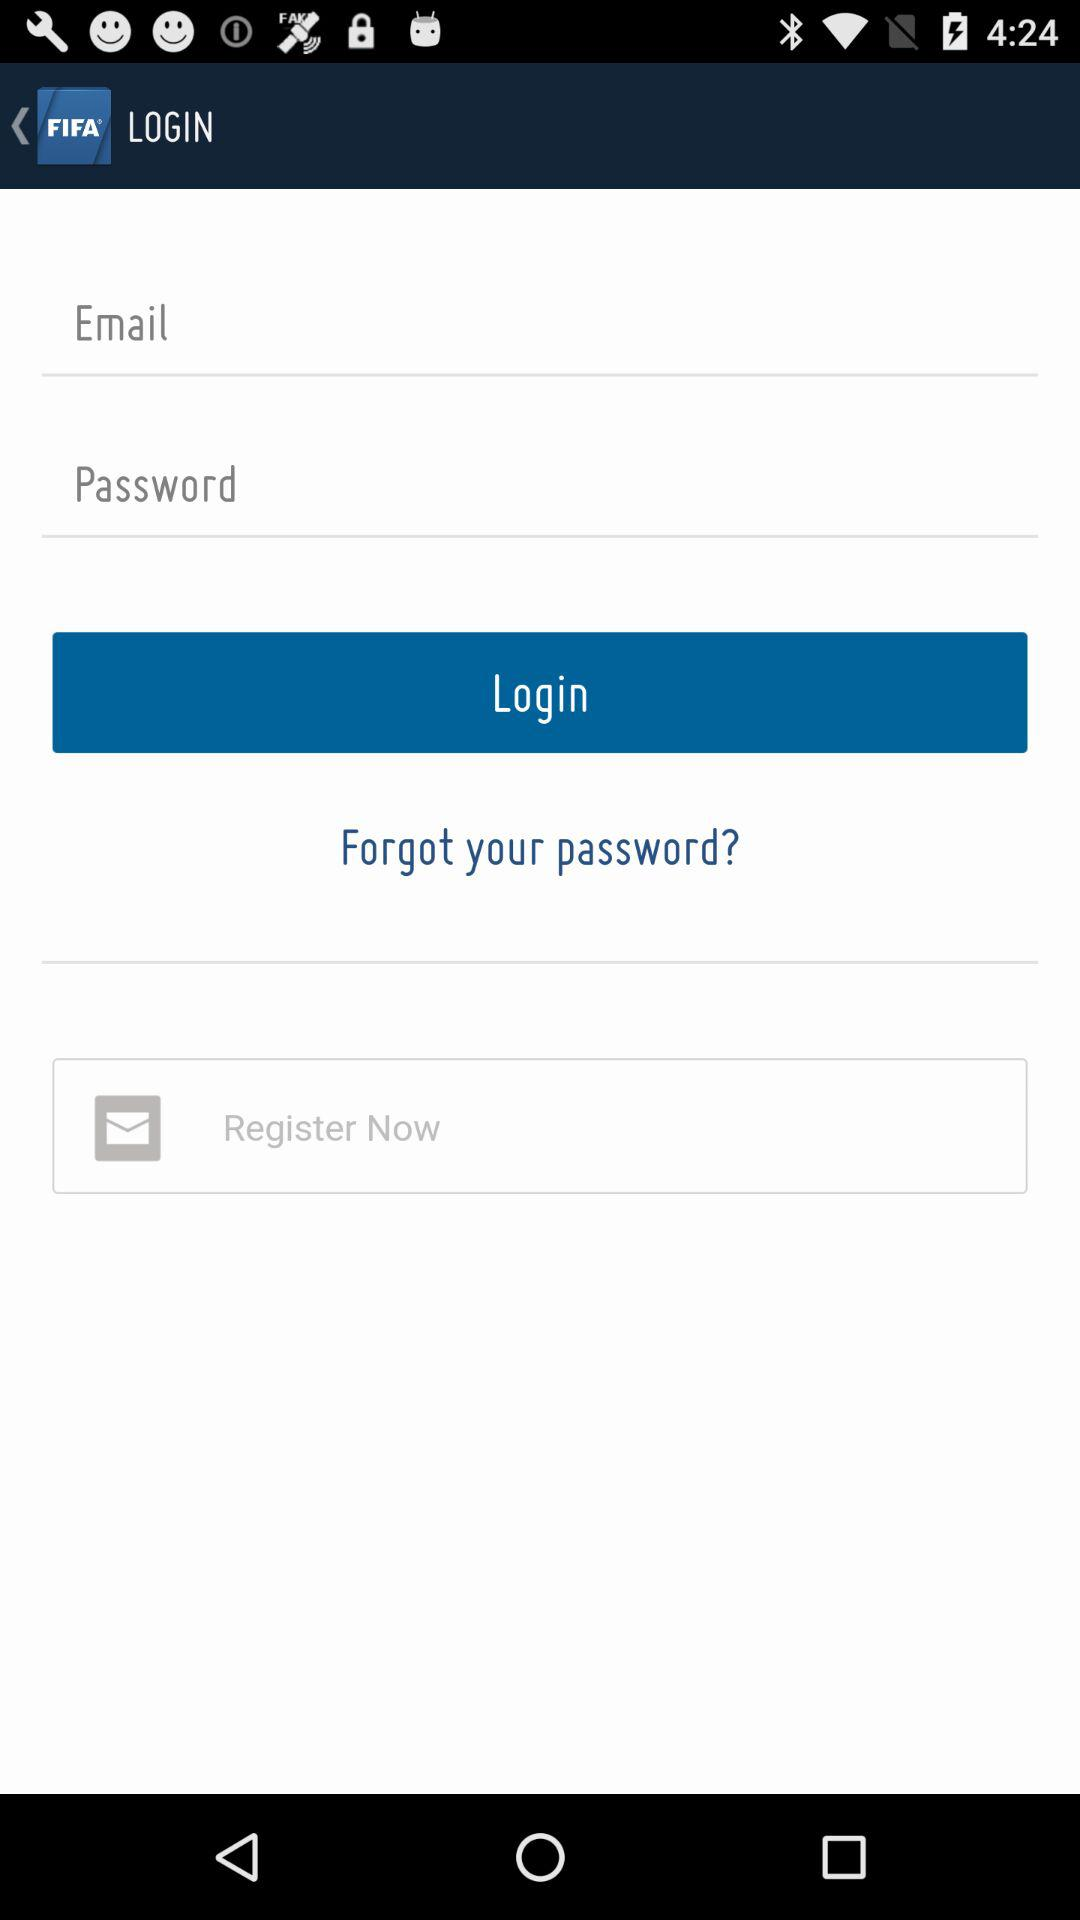What is the name of the application? The name of the application is "FIFA". 